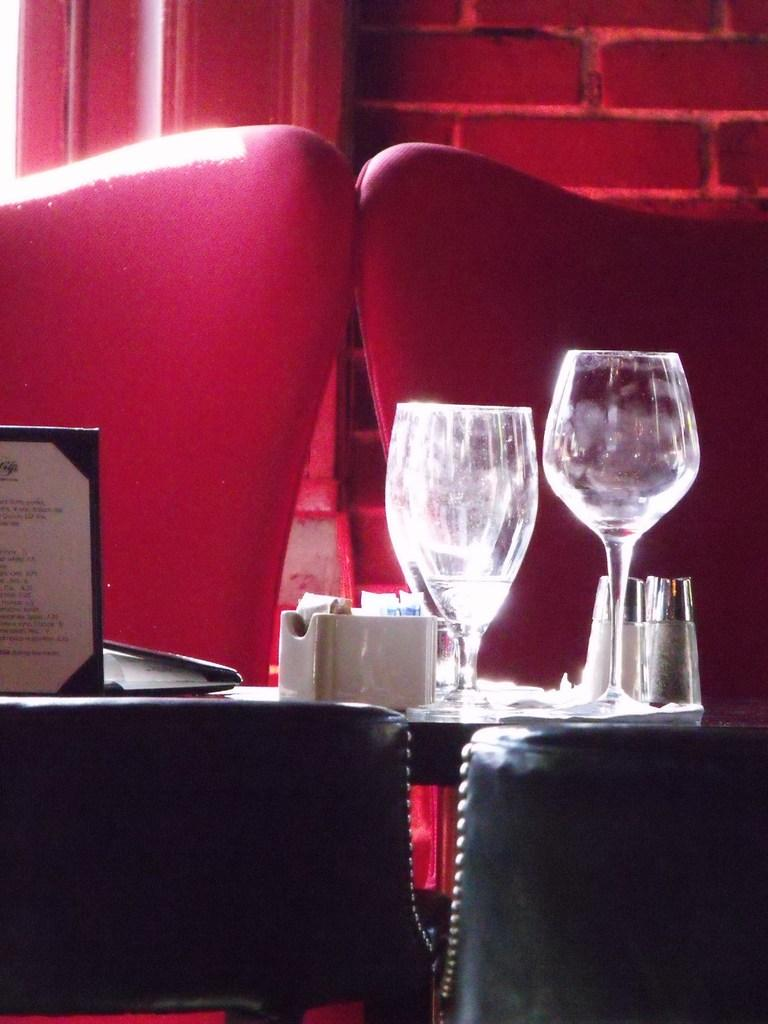What objects are on the table in the image? There are glasses, bottles, and a paper on the table in the image. What type of furniture is present in the image? There are chairs in the image. What is the background of the image? There is a wall in the image. What type of care is being provided to the carpenter in the image? There is no carpenter present in the image, and therefore no care is being provided. 